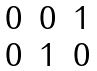Convert formula to latex. <formula><loc_0><loc_0><loc_500><loc_500>\begin{matrix} 0 & 0 & 1 \\ 0 & 1 & 0 \end{matrix}</formula> 